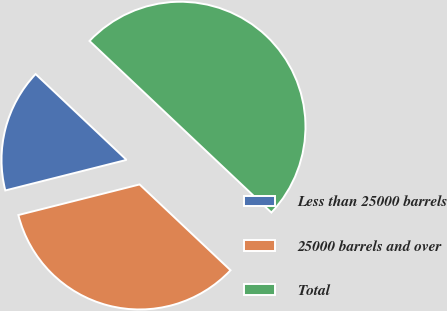Convert chart. <chart><loc_0><loc_0><loc_500><loc_500><pie_chart><fcel>Less than 25000 barrels<fcel>25000 barrels and over<fcel>Total<nl><fcel>15.97%<fcel>34.03%<fcel>50.0%<nl></chart> 